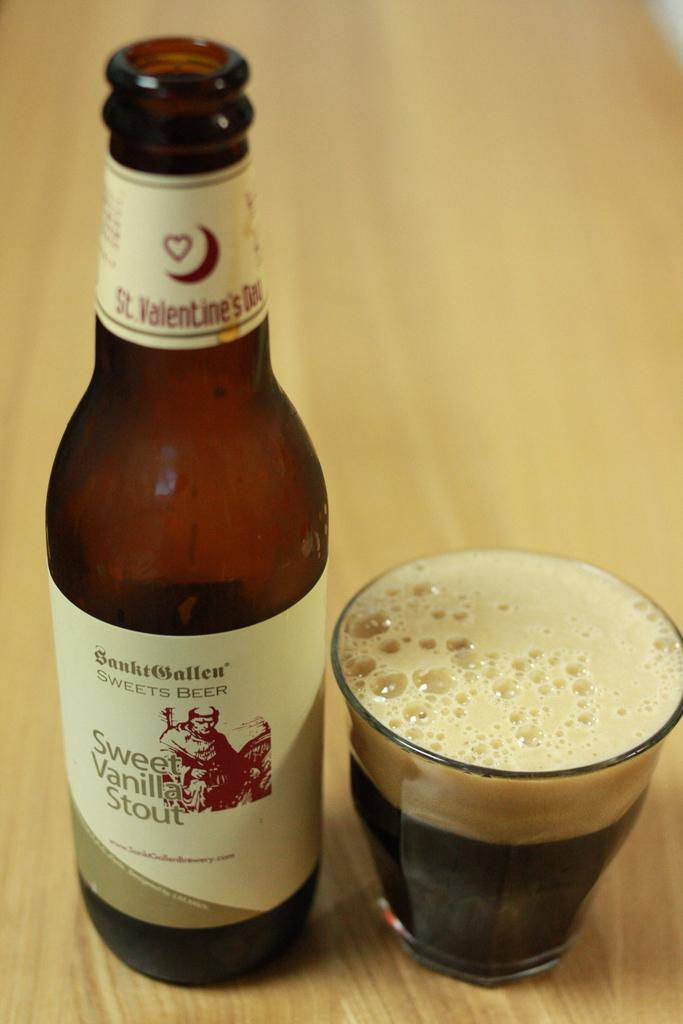<image>
Render a clear and concise summary of the photo. A bottle of Sweet Vanilla Stout next to a glass. 